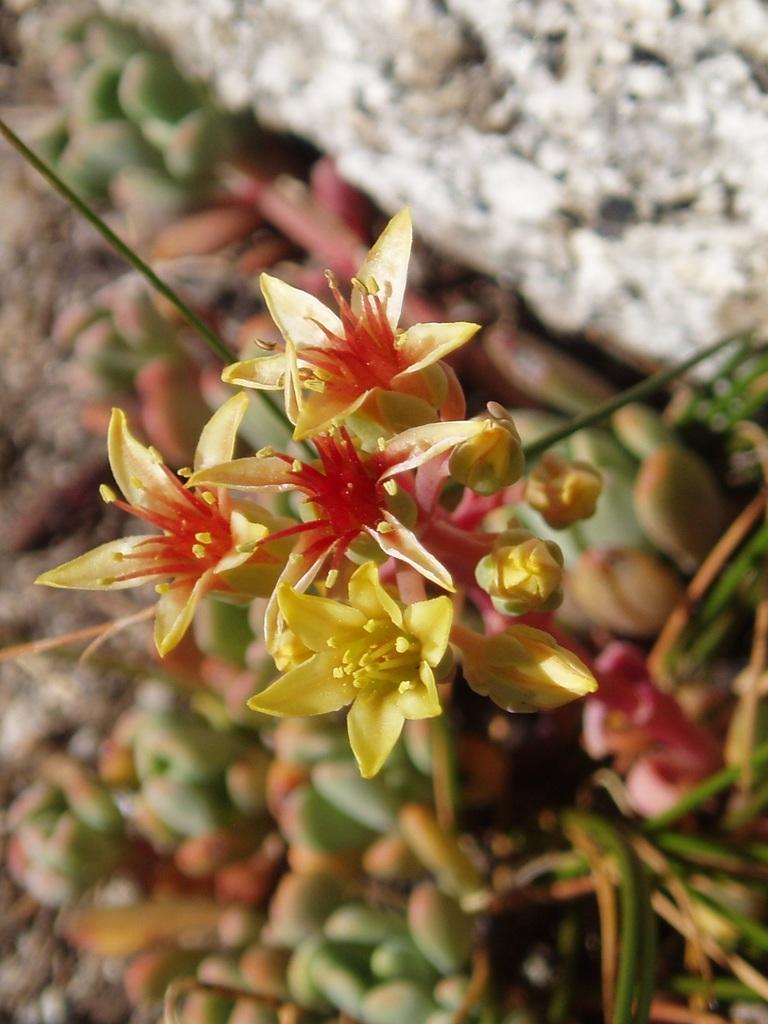Could you give a brief overview of what you see in this image? In this image we can see flowers and buds. In the top right, we can see a rock. The background of the image is blurred. 